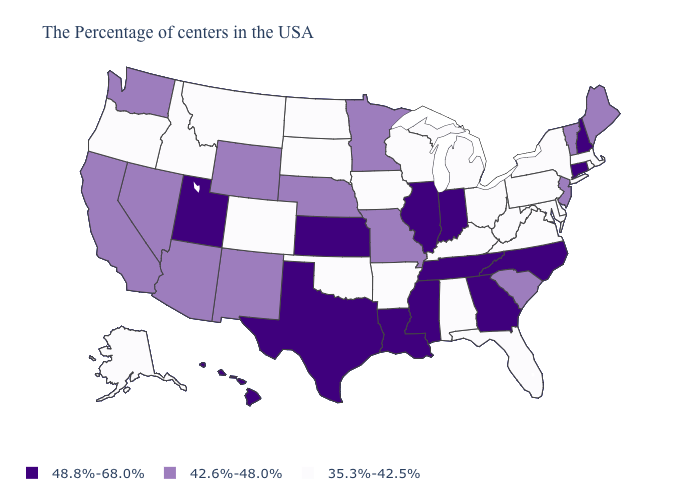What is the highest value in the USA?
Give a very brief answer. 48.8%-68.0%. Does Hawaii have the lowest value in the USA?
Short answer required. No. What is the value of Louisiana?
Keep it brief. 48.8%-68.0%. What is the value of South Dakota?
Quick response, please. 35.3%-42.5%. What is the value of Alaska?
Answer briefly. 35.3%-42.5%. What is the value of Kentucky?
Concise answer only. 35.3%-42.5%. What is the value of Alabama?
Write a very short answer. 35.3%-42.5%. Among the states that border Kansas , does Oklahoma have the highest value?
Give a very brief answer. No. What is the value of Illinois?
Write a very short answer. 48.8%-68.0%. What is the value of South Carolina?
Keep it brief. 42.6%-48.0%. Which states have the highest value in the USA?
Keep it brief. New Hampshire, Connecticut, North Carolina, Georgia, Indiana, Tennessee, Illinois, Mississippi, Louisiana, Kansas, Texas, Utah, Hawaii. Name the states that have a value in the range 35.3%-42.5%?
Quick response, please. Massachusetts, Rhode Island, New York, Delaware, Maryland, Pennsylvania, Virginia, West Virginia, Ohio, Florida, Michigan, Kentucky, Alabama, Wisconsin, Arkansas, Iowa, Oklahoma, South Dakota, North Dakota, Colorado, Montana, Idaho, Oregon, Alaska. What is the lowest value in the West?
Answer briefly. 35.3%-42.5%. Name the states that have a value in the range 48.8%-68.0%?
Be succinct. New Hampshire, Connecticut, North Carolina, Georgia, Indiana, Tennessee, Illinois, Mississippi, Louisiana, Kansas, Texas, Utah, Hawaii. Among the states that border Louisiana , does Arkansas have the lowest value?
Write a very short answer. Yes. 